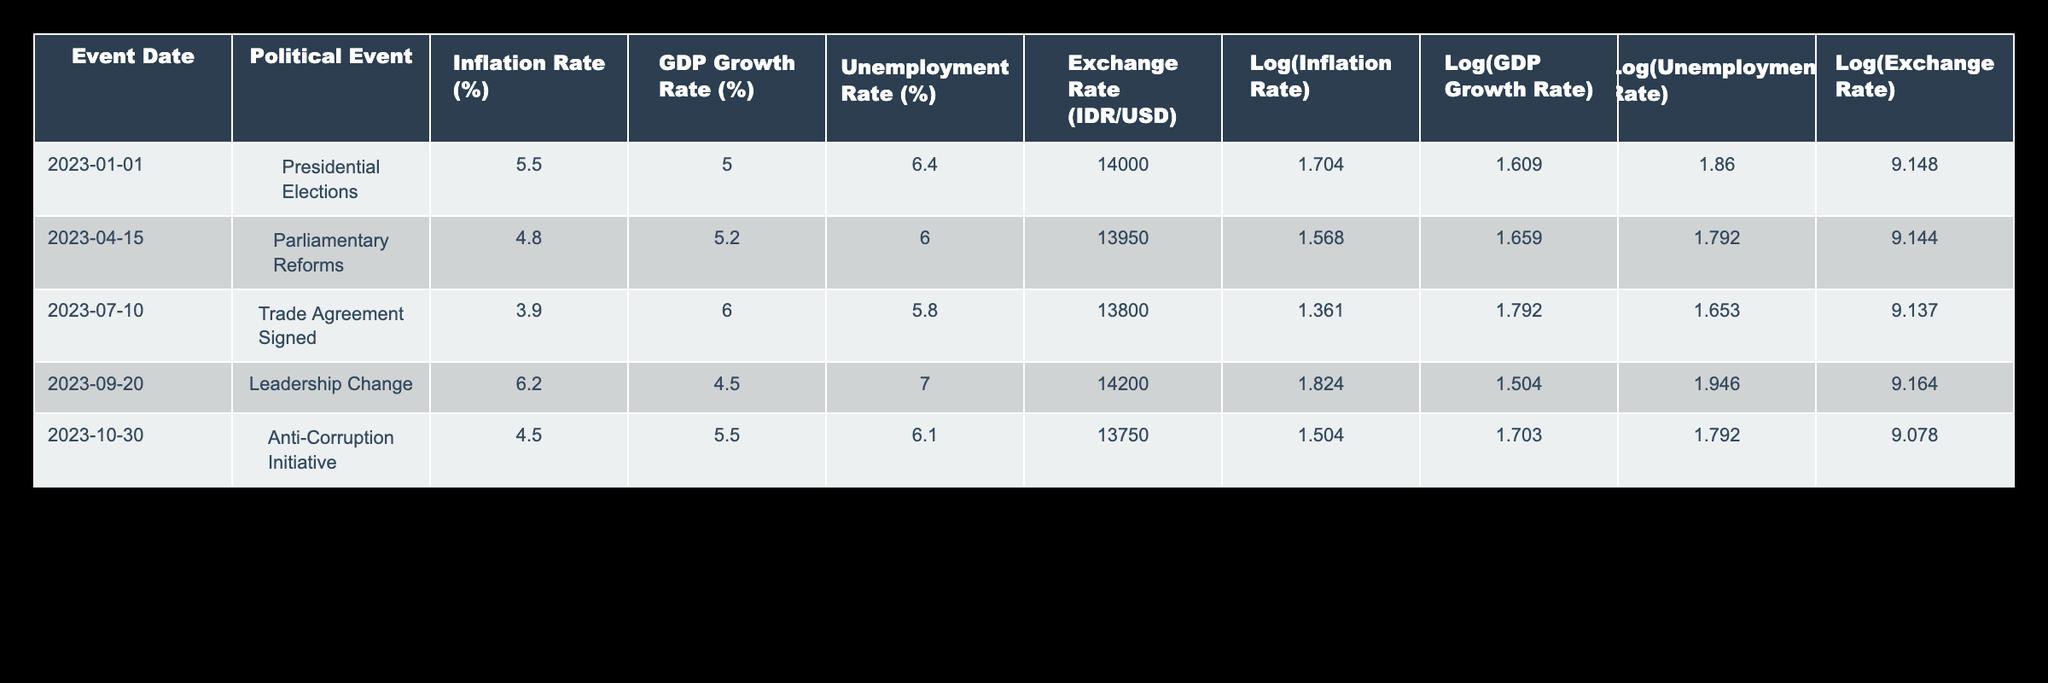What was the inflation rate during the Presidential Elections on 2023-01-01? Referring to the table, the inflation rate listed for the event on this date is 5.5%.
Answer: 5.5% What was the GDP growth rate for the Trade Agreement Signed on 2023-07-10? According to the table, the GDP growth rate for this event is 6.0%.
Answer: 6.0% Which political event correlates with the highest unemployment rate in this data? The Leadership Change on 2023-09-20 is associated with the highest unemployment rate of 7.0% according to the table.
Answer: Leadership Change Is the exchange rate lower during the Anti-Corruption Initiative compared to the Presidential Elections? The exchange rate for the Anti-Corruption Initiative on 2023-10-30 is 13,750 IDR/USD, which is lower than the 14,000 IDR/USD during the Presidential Elections. Therefore, the statement is true.
Answer: Yes What is the average inflation rate across all events listed in the table? To find the average inflation rate, we sum the rates: 5.5 + 4.8 + 3.9 + 6.2 + 4.5 = 25.9%. With 5 events, we divide by 5: 25.9/5 = 5.18%.
Answer: 5.18% How many political events resulted in a GDP growth rate greater than 5%? The events with GDP growth rates greater than 5% are the Presidential Elections (5.0%), Parliamentary Reforms (5.2%), Trade Agreement Signed (6.0%), and Anti-Corruption Initiative (5.5%). This gives us a total of 4 events.
Answer: 4 Does a decrease in the inflation rate correlate with an increase in the GDP growth rate based on the data? Looking at the table, between the Presidential Elections (5.5% inflation, 5.0% GDP) and Trade Agreement Signed (3.9% inflation, 6.0% GDP), there is a decrease in inflation and an increase in GDP. Similarly, from the Parliamentary Reforms to the Trade Agreement, the inflation rate decreased from 4.8% to 3.9%, while GDP grew from 5.2% to 6.0%. Therefore, it's true that a decrease in inflation correlates with an increase in GDP growth rate.
Answer: Yes Which political event is associated with the highest exchange rate value and what is that value? The table indicates that the highest exchange rate is 14,200 IDR/USD during the Leadership Change event on 2023-09-20.
Answer: 14,200 IDR/USD What was the change in unemployment rate from the Trade Agreement Signed to the Anti-Corruption Initiative? The unemployment rate dropped from 5.8% (Trade Agreement Signed) to 6.1% (Anti-Corruption Initiative), resulting in a change of 0.3%. That means unemployment actually increased by 0.3%.
Answer: Increased by 0.3% If we analyze the logs of the inflation rates, which event had the lowest logarithmic value? In the table, the lowest logarithmic value for inflation rate is 1.361, corresponding to the Trade Agreement Signed on 2023-07-10.
Answer: Trade Agreement Signed 